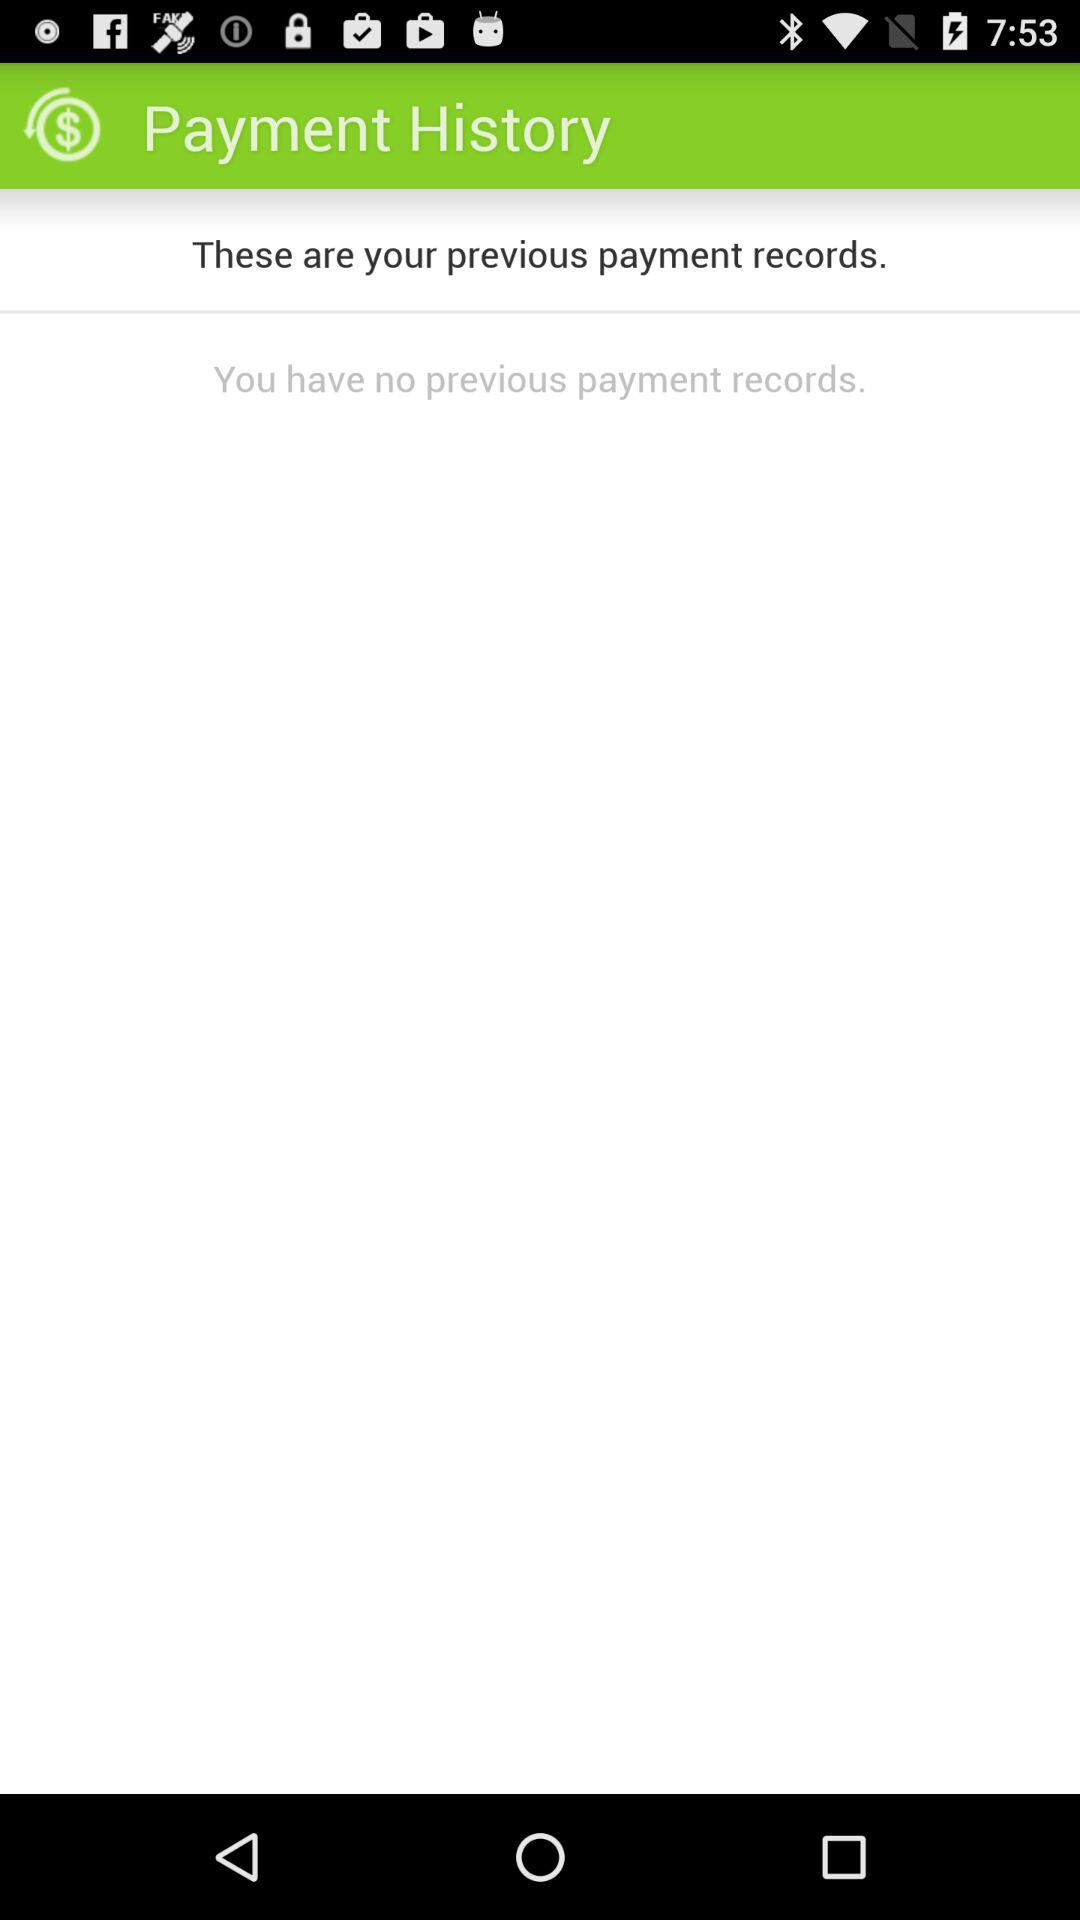How many payment records do I have?
Answer the question using a single word or phrase. 0 